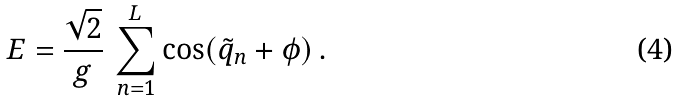<formula> <loc_0><loc_0><loc_500><loc_500>E = \frac { \sqrt { 2 } } { g } \, \sum _ { n = 1 } ^ { L } \cos ( \tilde { q } _ { n } + \phi ) \, .</formula> 